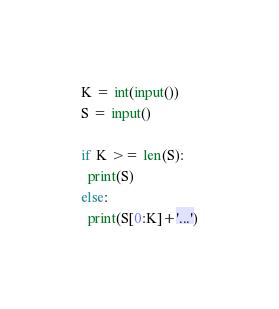<code> <loc_0><loc_0><loc_500><loc_500><_Python_>K = int(input())
S = input()

if K >= len(S):
  print(S)
else:
  print(S[0:K]+'...')
</code> 